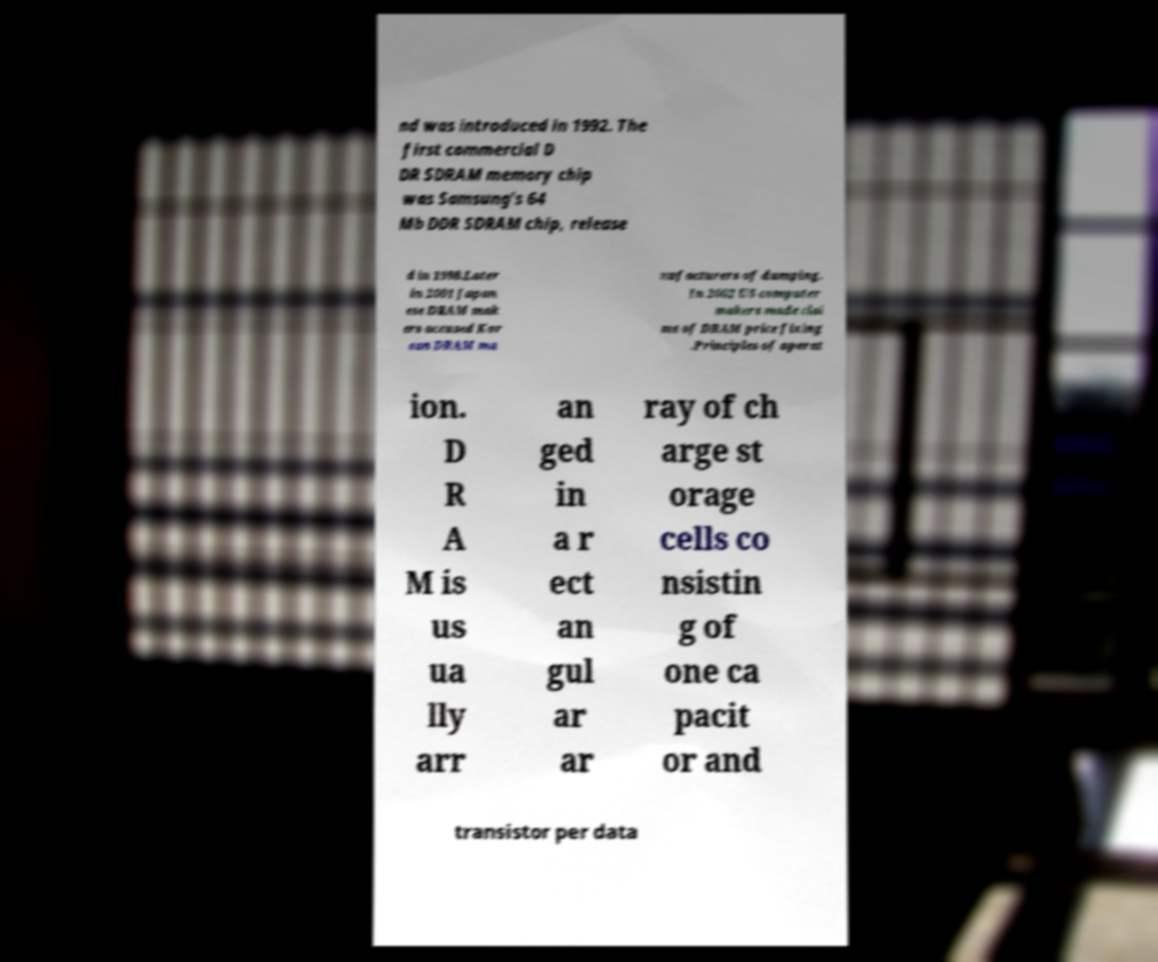What messages or text are displayed in this image? I need them in a readable, typed format. nd was introduced in 1992. The first commercial D DR SDRAM memory chip was Samsung's 64 Mb DDR SDRAM chip, release d in 1998.Later in 2001 Japan ese DRAM mak ers accused Kor ean DRAM ma nufacturers of dumping. In 2002 US computer makers made clai ms of DRAM price fixing .Principles of operat ion. D R A M is us ua lly arr an ged in a r ect an gul ar ar ray of ch arge st orage cells co nsistin g of one ca pacit or and transistor per data 